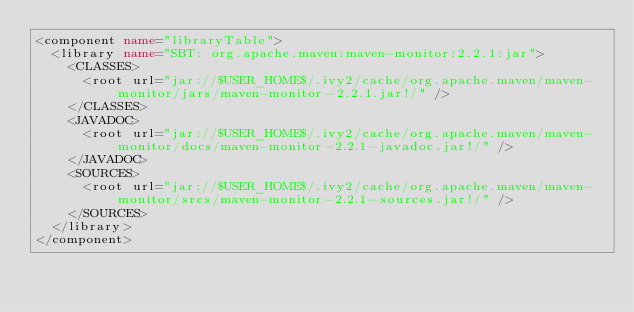<code> <loc_0><loc_0><loc_500><loc_500><_XML_><component name="libraryTable">
  <library name="SBT: org.apache.maven:maven-monitor:2.2.1:jar">
    <CLASSES>
      <root url="jar://$USER_HOME$/.ivy2/cache/org.apache.maven/maven-monitor/jars/maven-monitor-2.2.1.jar!/" />
    </CLASSES>
    <JAVADOC>
      <root url="jar://$USER_HOME$/.ivy2/cache/org.apache.maven/maven-monitor/docs/maven-monitor-2.2.1-javadoc.jar!/" />
    </JAVADOC>
    <SOURCES>
      <root url="jar://$USER_HOME$/.ivy2/cache/org.apache.maven/maven-monitor/srcs/maven-monitor-2.2.1-sources.jar!/" />
    </SOURCES>
  </library>
</component></code> 